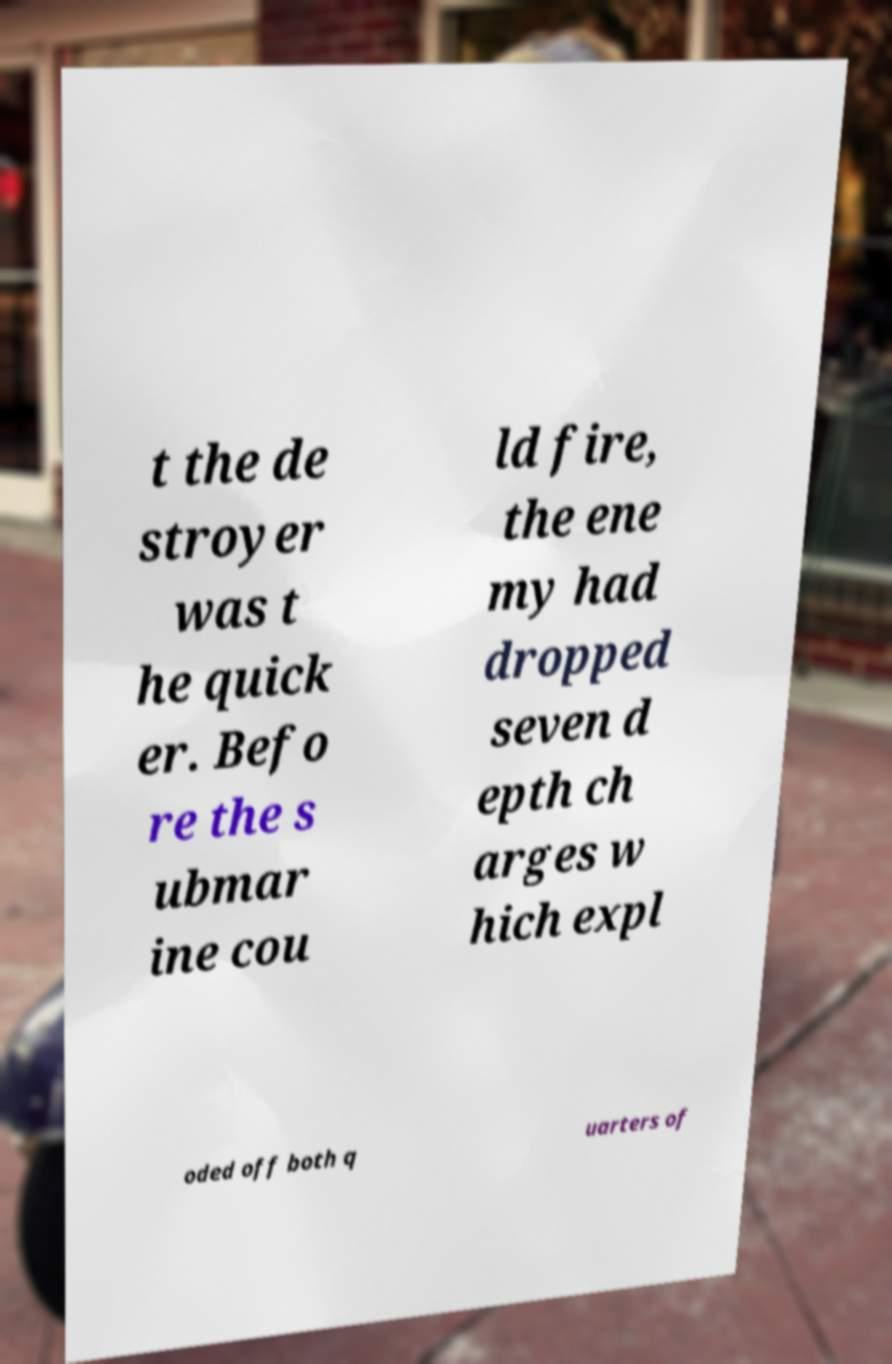What messages or text are displayed in this image? I need them in a readable, typed format. t the de stroyer was t he quick er. Befo re the s ubmar ine cou ld fire, the ene my had dropped seven d epth ch arges w hich expl oded off both q uarters of 